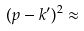<formula> <loc_0><loc_0><loc_500><loc_500>( p - k ^ { \prime } ) ^ { 2 } \approx</formula> 